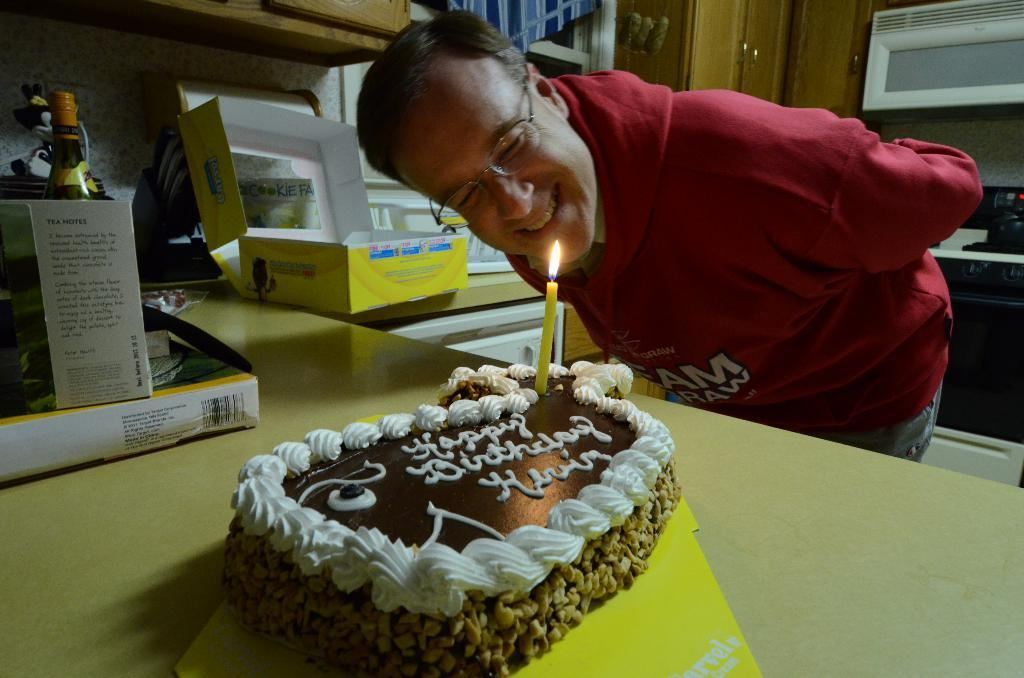What is the main object on the table in the image? There is a cake on a table in the image. Can you describe the person on the right side of the image? Unfortunately, the provided facts do not give any information about the person's appearance or actions. What is located on the left side of the image? There is a bottle on the left side of the image. What is the tendency of the sand in the image? There is no sand present in the image, so it is not possible to determine its tendency. 